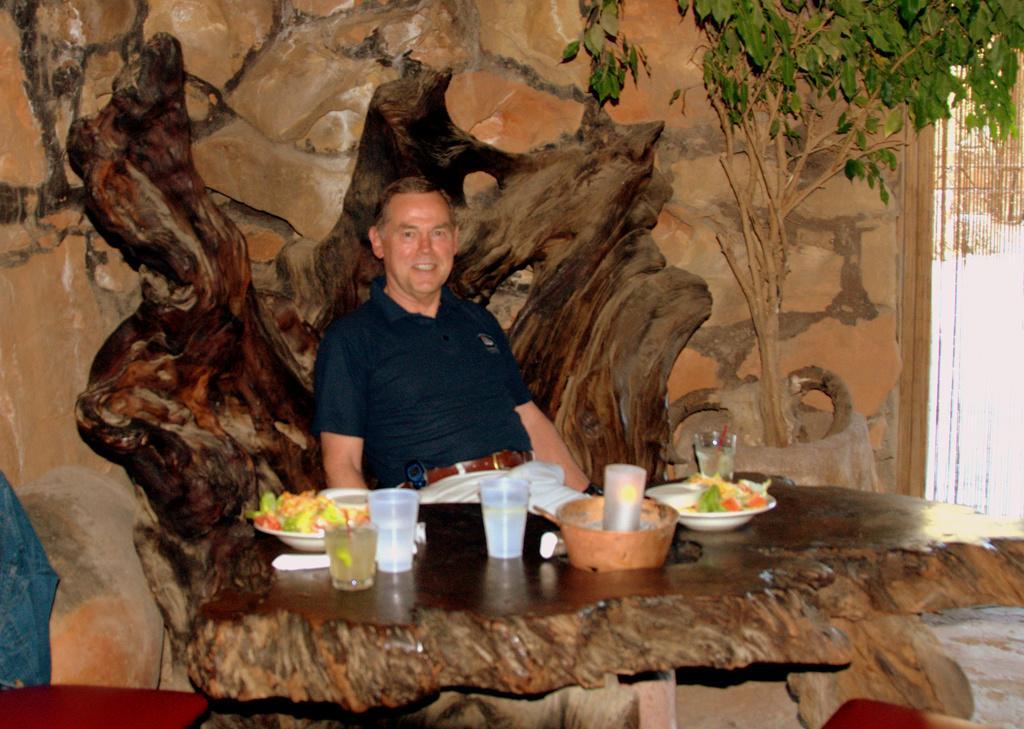How would you summarize this image in a sentence or two? In this image there is a man sitting in a wood chair ,and on table there are glasses, plates, food, bowl, straws,and the back ground there is a wall poster or wall, tree. 